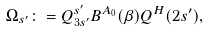<formula> <loc_0><loc_0><loc_500><loc_500>\Omega _ { s ^ { \prime } } \colon = Q ^ { s ^ { \prime } } _ { 3 s ^ { \prime } } B ^ { A _ { 0 } } ( \beta ) Q ^ { H } ( 2 s ^ { \prime } ) ,</formula> 